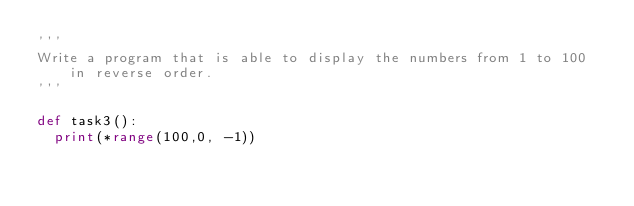<code> <loc_0><loc_0><loc_500><loc_500><_Python_>'''
Write a program that is able to display the numbers from 1 to 100 in reverse order.
'''

def task3():
  print(*range(100,0, -1))</code> 